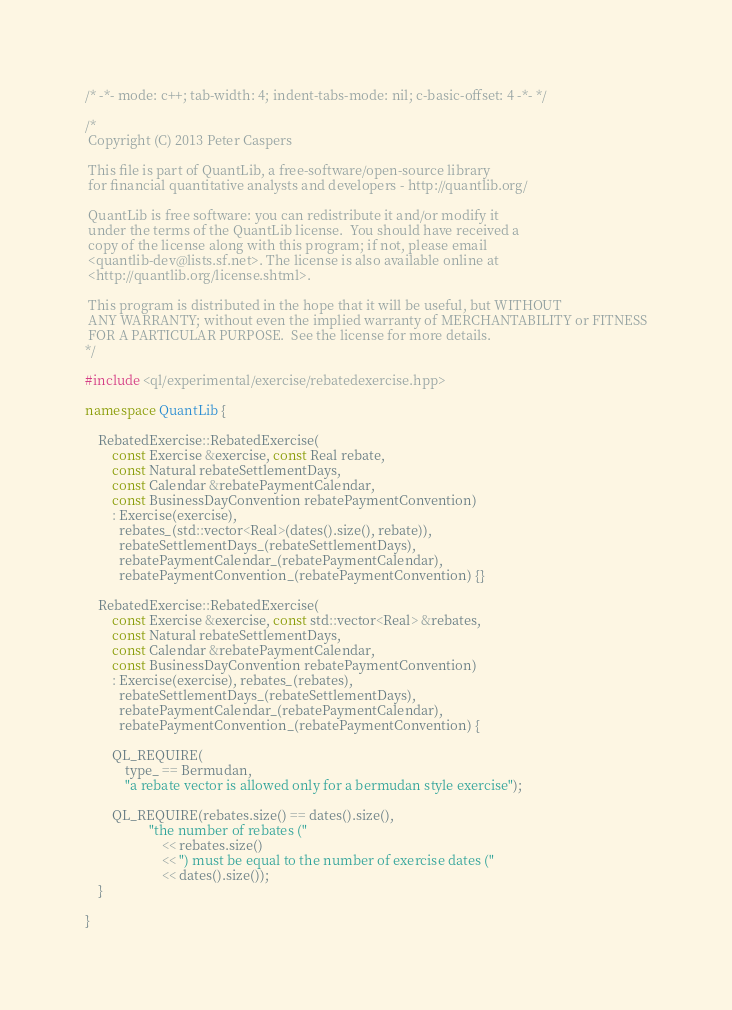Convert code to text. <code><loc_0><loc_0><loc_500><loc_500><_C++_>/* -*- mode: c++; tab-width: 4; indent-tabs-mode: nil; c-basic-offset: 4 -*- */

/*
 Copyright (C) 2013 Peter Caspers

 This file is part of QuantLib, a free-software/open-source library
 for financial quantitative analysts and developers - http://quantlib.org/

 QuantLib is free software: you can redistribute it and/or modify it
 under the terms of the QuantLib license.  You should have received a
 copy of the license along with this program; if not, please email
 <quantlib-dev@lists.sf.net>. The license is also available online at
 <http://quantlib.org/license.shtml>.

 This program is distributed in the hope that it will be useful, but WITHOUT
 ANY WARRANTY; without even the implied warranty of MERCHANTABILITY or FITNESS
 FOR A PARTICULAR PURPOSE.  See the license for more details.
*/

#include <ql/experimental/exercise/rebatedexercise.hpp>

namespace QuantLib {

    RebatedExercise::RebatedExercise(
        const Exercise &exercise, const Real rebate,
        const Natural rebateSettlementDays,
        const Calendar &rebatePaymentCalendar,
        const BusinessDayConvention rebatePaymentConvention)
        : Exercise(exercise),
          rebates_(std::vector<Real>(dates().size(), rebate)),
          rebateSettlementDays_(rebateSettlementDays),
          rebatePaymentCalendar_(rebatePaymentCalendar),
          rebatePaymentConvention_(rebatePaymentConvention) {}

    RebatedExercise::RebatedExercise(
        const Exercise &exercise, const std::vector<Real> &rebates,
        const Natural rebateSettlementDays,
        const Calendar &rebatePaymentCalendar,
        const BusinessDayConvention rebatePaymentConvention)
        : Exercise(exercise), rebates_(rebates),
          rebateSettlementDays_(rebateSettlementDays),
          rebatePaymentCalendar_(rebatePaymentCalendar),
          rebatePaymentConvention_(rebatePaymentConvention) {

        QL_REQUIRE(
            type_ == Bermudan,
            "a rebate vector is allowed only for a bermudan style exercise");

        QL_REQUIRE(rebates.size() == dates().size(),
                   "the number of rebates ("
                       << rebates.size()
                       << ") must be equal to the number of exercise dates ("
                       << dates().size());
    }

}
</code> 